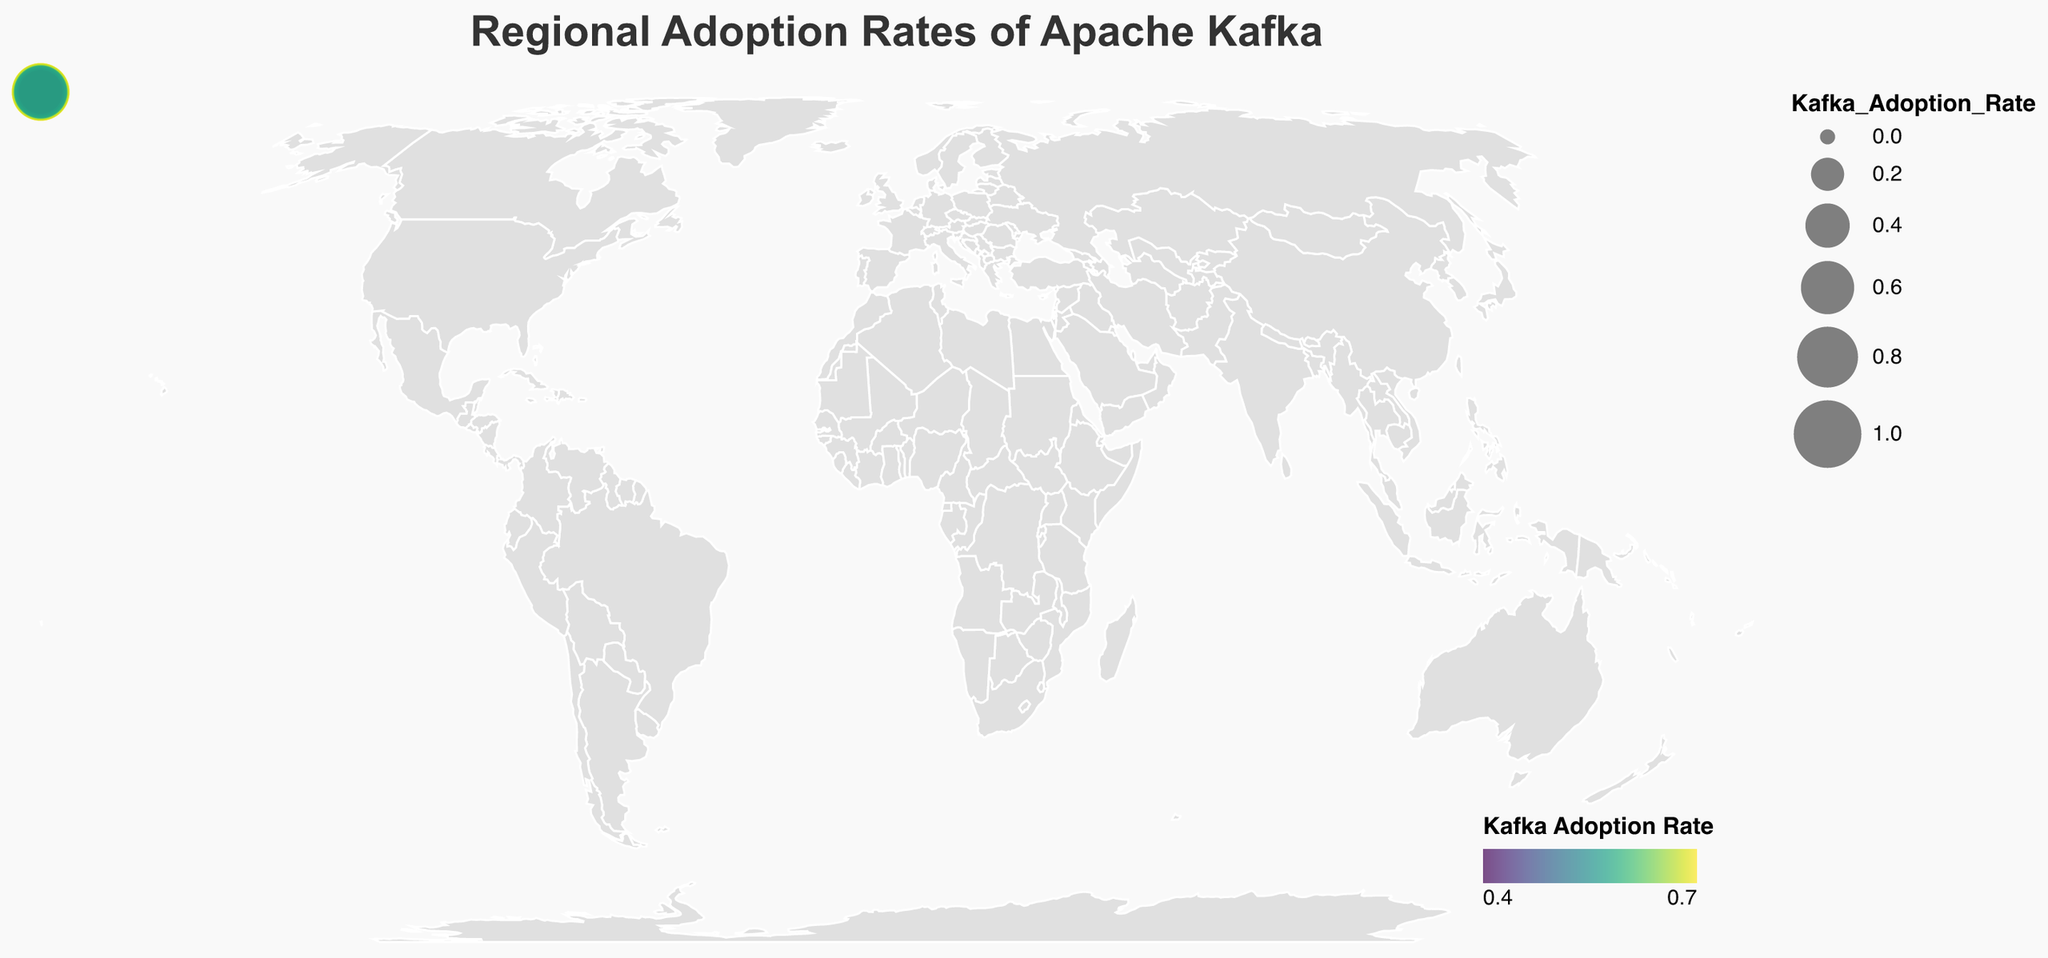What is the title of the plot? The title of the plot is displayed at the top and describes what the plot is about.
Answer: Regional Adoption Rates of Apache Kafka Which continent shows the highest adoption rate for Apache Kafka? By examining the plot, North America is highlighted with relatively larger circle sizes, indicating a higher adoption rate.
Answer: North America What are the adoption rates of Apache Kafka in Europe? The plot shows different sized and colored circles for United Kingdom, Germany, and France. The sizes and colors reflect these adoption rates: 0.68, 0.71, and 0.59, respectively.
Answer: United Kingdom: 0.68, Germany: 0.71, France: 0.59 Which country in Asia has the lowest adoption rate of Apache Kafka? Comparing the sizes and colors of circles for India, Japan, and Singapore, Japan has the smallest size and a darker color, indicating a lower adoption rate.
Answer: Japan What is the difference in Kafka adoption rates between the United States and Brazil? From the plot, the United States has a rate of 0.72, and Brazil has a rate of 0.54. The difference is calculated by subtracting 0.54 from 0.72.
Answer: 0.18 Which continent has the least adoption rate for Apache Kafka? The circles representing Africa (South Africa: 0.45, Nigeria: 0.39) are smaller and darker than other continents.
Answer: Africa How does the Kafka adoption rate in Canada compare to Australia? From the plot, Canada has an adoption rate of 0.65, while Australia has 0.61. Canada has a higher rate.
Answer: Canada What is the median adoption rate of all countries displayed in the plot? Ordering the rates: 0.39, 0.45, 0.48, 0.54, 0.57, 0.58, 0.59, 0.61, 0.63, 0.65, 0.68, 0.69, 0.71, 0.72. The median rate is the average of the 7th and 8th values.
Answer: 0.59 How many countries in total are visualized in the plot? Each country is represented by a circle. Counting all the circles in North America, Europe, Asia, South America, Africa, and Oceania provides the total number.
Answer: 14 